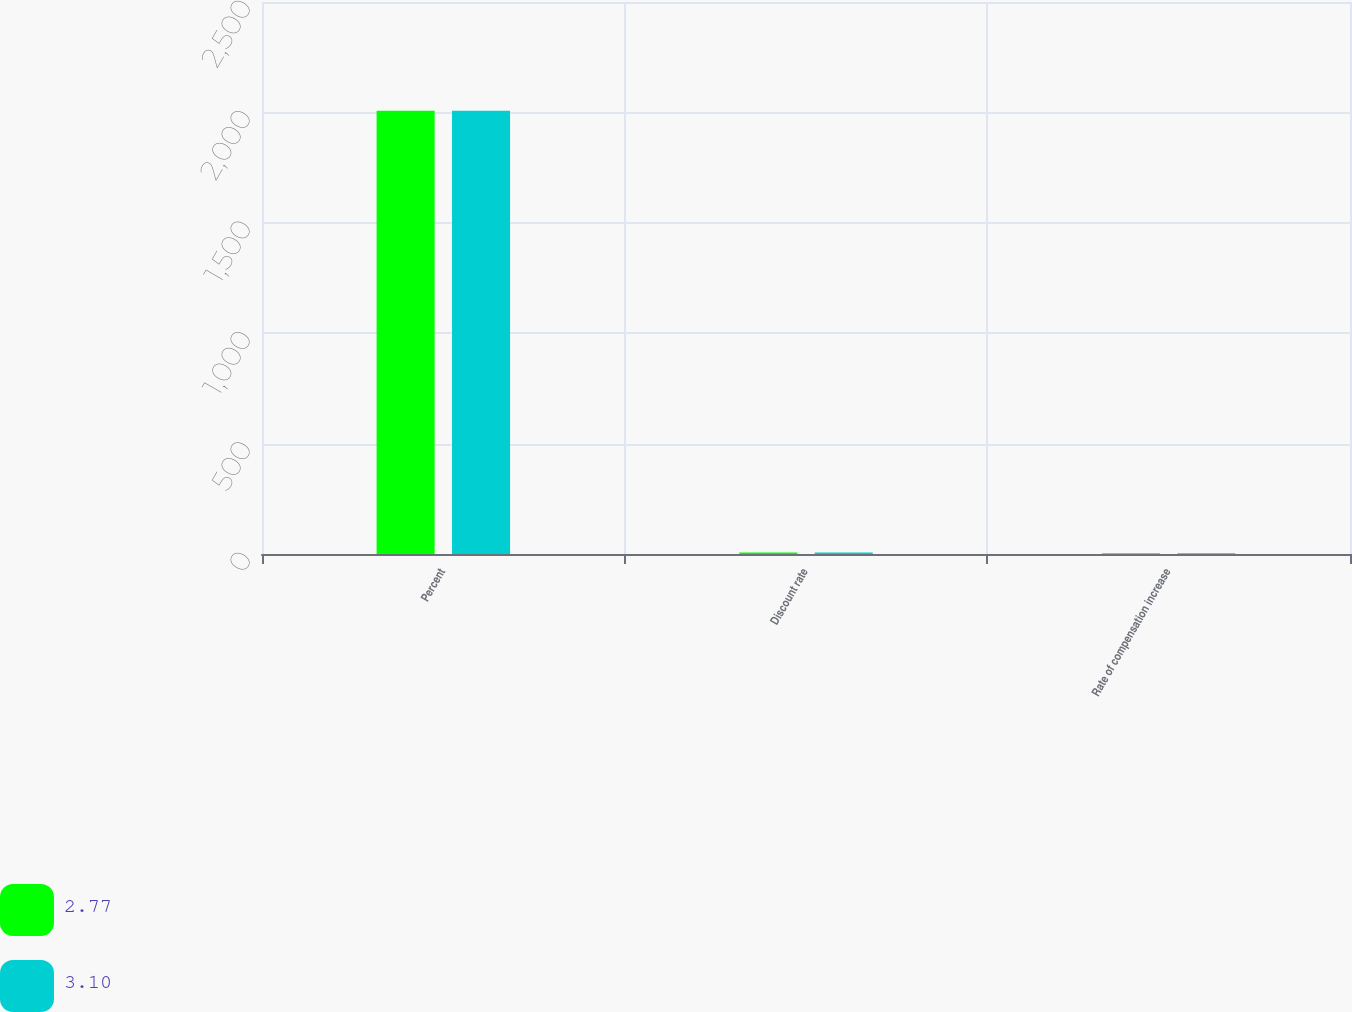Convert chart to OTSL. <chart><loc_0><loc_0><loc_500><loc_500><stacked_bar_chart><ecel><fcel>Percent<fcel>Discount rate<fcel>Rate of compensation increase<nl><fcel>2.77<fcel>2008<fcel>7<fcel>3.5<nl><fcel>3.1<fcel>2007<fcel>6.5<fcel>3.5<nl></chart> 